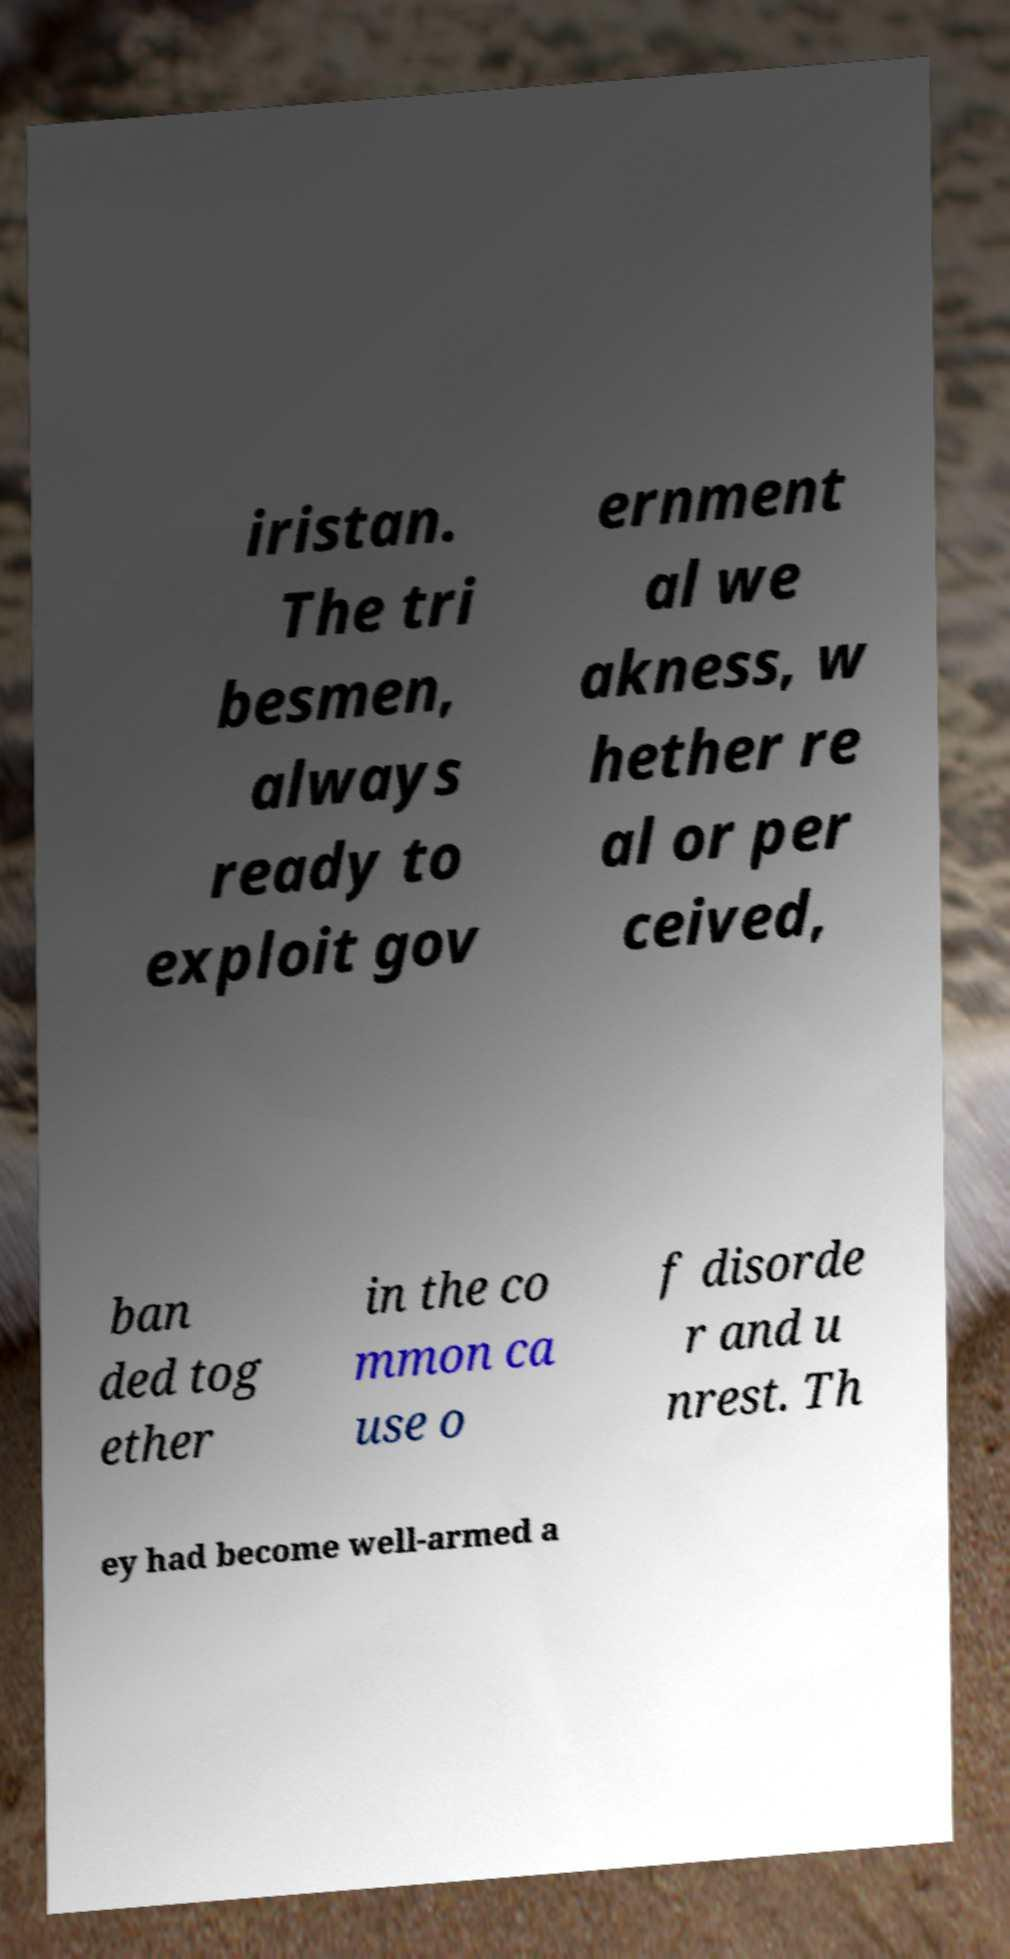What messages or text are displayed in this image? I need them in a readable, typed format. iristan. The tri besmen, always ready to exploit gov ernment al we akness, w hether re al or per ceived, ban ded tog ether in the co mmon ca use o f disorde r and u nrest. Th ey had become well-armed a 